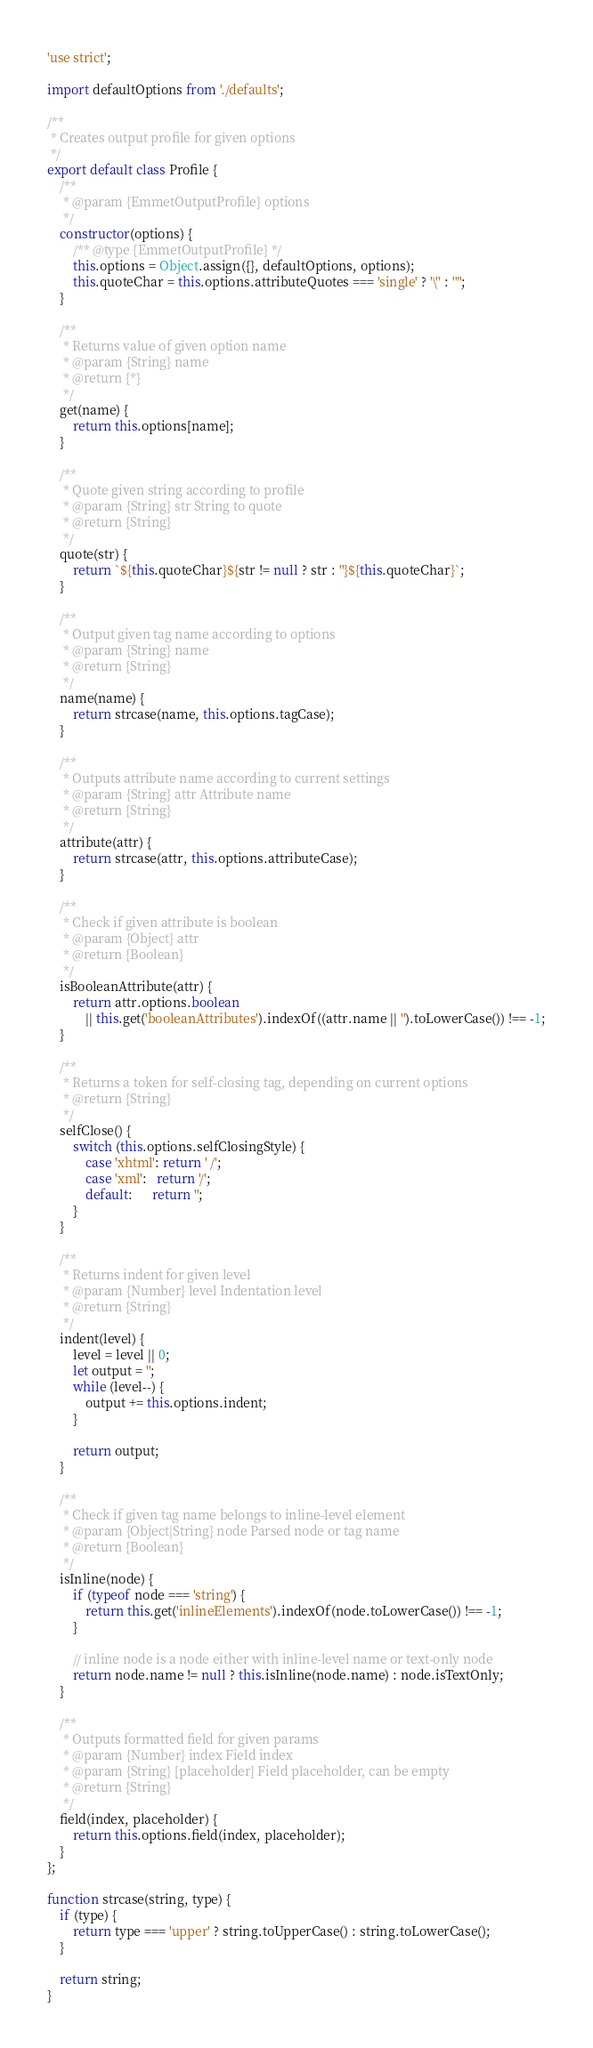Convert code to text. <code><loc_0><loc_0><loc_500><loc_500><_JavaScript_>'use strict';

import defaultOptions from './defaults';

/**
 * Creates output profile for given options
 */
export default class Profile {
	/**
	 * @param {EmmetOutputProfile} options 
	 */
    constructor(options) {
		/** @type {EmmetOutputProfile} */
		this.options = Object.assign({}, defaultOptions, options);
		this.quoteChar = this.options.attributeQuotes === 'single' ? '\'' : '"';
    }

	/**
	 * Returns value of given option name
	 * @param {String} name
	 * @return {*}
	 */
	get(name) {
		return this.options[name];
	}

    /**
     * Quote given string according to profile
     * @param {String} str String to quote
     * @return {String}
     */
    quote(str) {
        return `${this.quoteChar}${str != null ? str : ''}${this.quoteChar}`;
    }

    /**
     * Output given tag name according to options
     * @param {String} name
     * @return {String}
     */
    name(name) {
        return strcase(name, this.options.tagCase);
    }

	/**
	 * Outputs attribute name according to current settings
	 * @param {String} attr Attribute name
	 * @return {String}
	 */
    attribute(attr) {
        return strcase(attr, this.options.attributeCase);
    }

    /**
     * Check if given attribute is boolean
     * @param {Object} attr
     * @return {Boolean}
     */
    isBooleanAttribute(attr) {
        return attr.options.boolean
			|| this.get('booleanAttributes').indexOf((attr.name || '').toLowerCase()) !== -1;
    }

	/**
	 * Returns a token for self-closing tag, depending on current options
	 * @return {String}
	 */
	selfClose() {
		switch (this.options.selfClosingStyle) {
			case 'xhtml': return ' /';
			case 'xml':   return '/';
			default:      return '';
		}
	}

	/**
	 * Returns indent for given level
	 * @param {Number} level Indentation level
	 * @return {String}
	 */
	indent(level) {
		level = level || 0;
		let output = '';
		while (level--) {
			output += this.options.indent;
		}

		return output;
	}

	/**
	 * Check if given tag name belongs to inline-level element
	 * @param {Object|String} node Parsed node or tag name
	 * @return {Boolean}
	 */
	isInline(node) {
        if (typeof node === 'string') {
            return this.get('inlineElements').indexOf(node.toLowerCase()) !== -1;
        }

        // inline node is a node either with inline-level name or text-only node
        return node.name != null ? this.isInline(node.name) : node.isTextOnly;
	}

	/**
	 * Outputs formatted field for given params
	 * @param {Number} index Field index
	 * @param {String} [placeholder] Field placeholder, can be empty
	 * @return {String}
	 */
	field(index, placeholder) {
		return this.options.field(index, placeholder);
	}
};

function strcase(string, type) {
    if (type) {
        return type === 'upper' ? string.toUpperCase() : string.toLowerCase();
	}
	
    return string;
}
</code> 